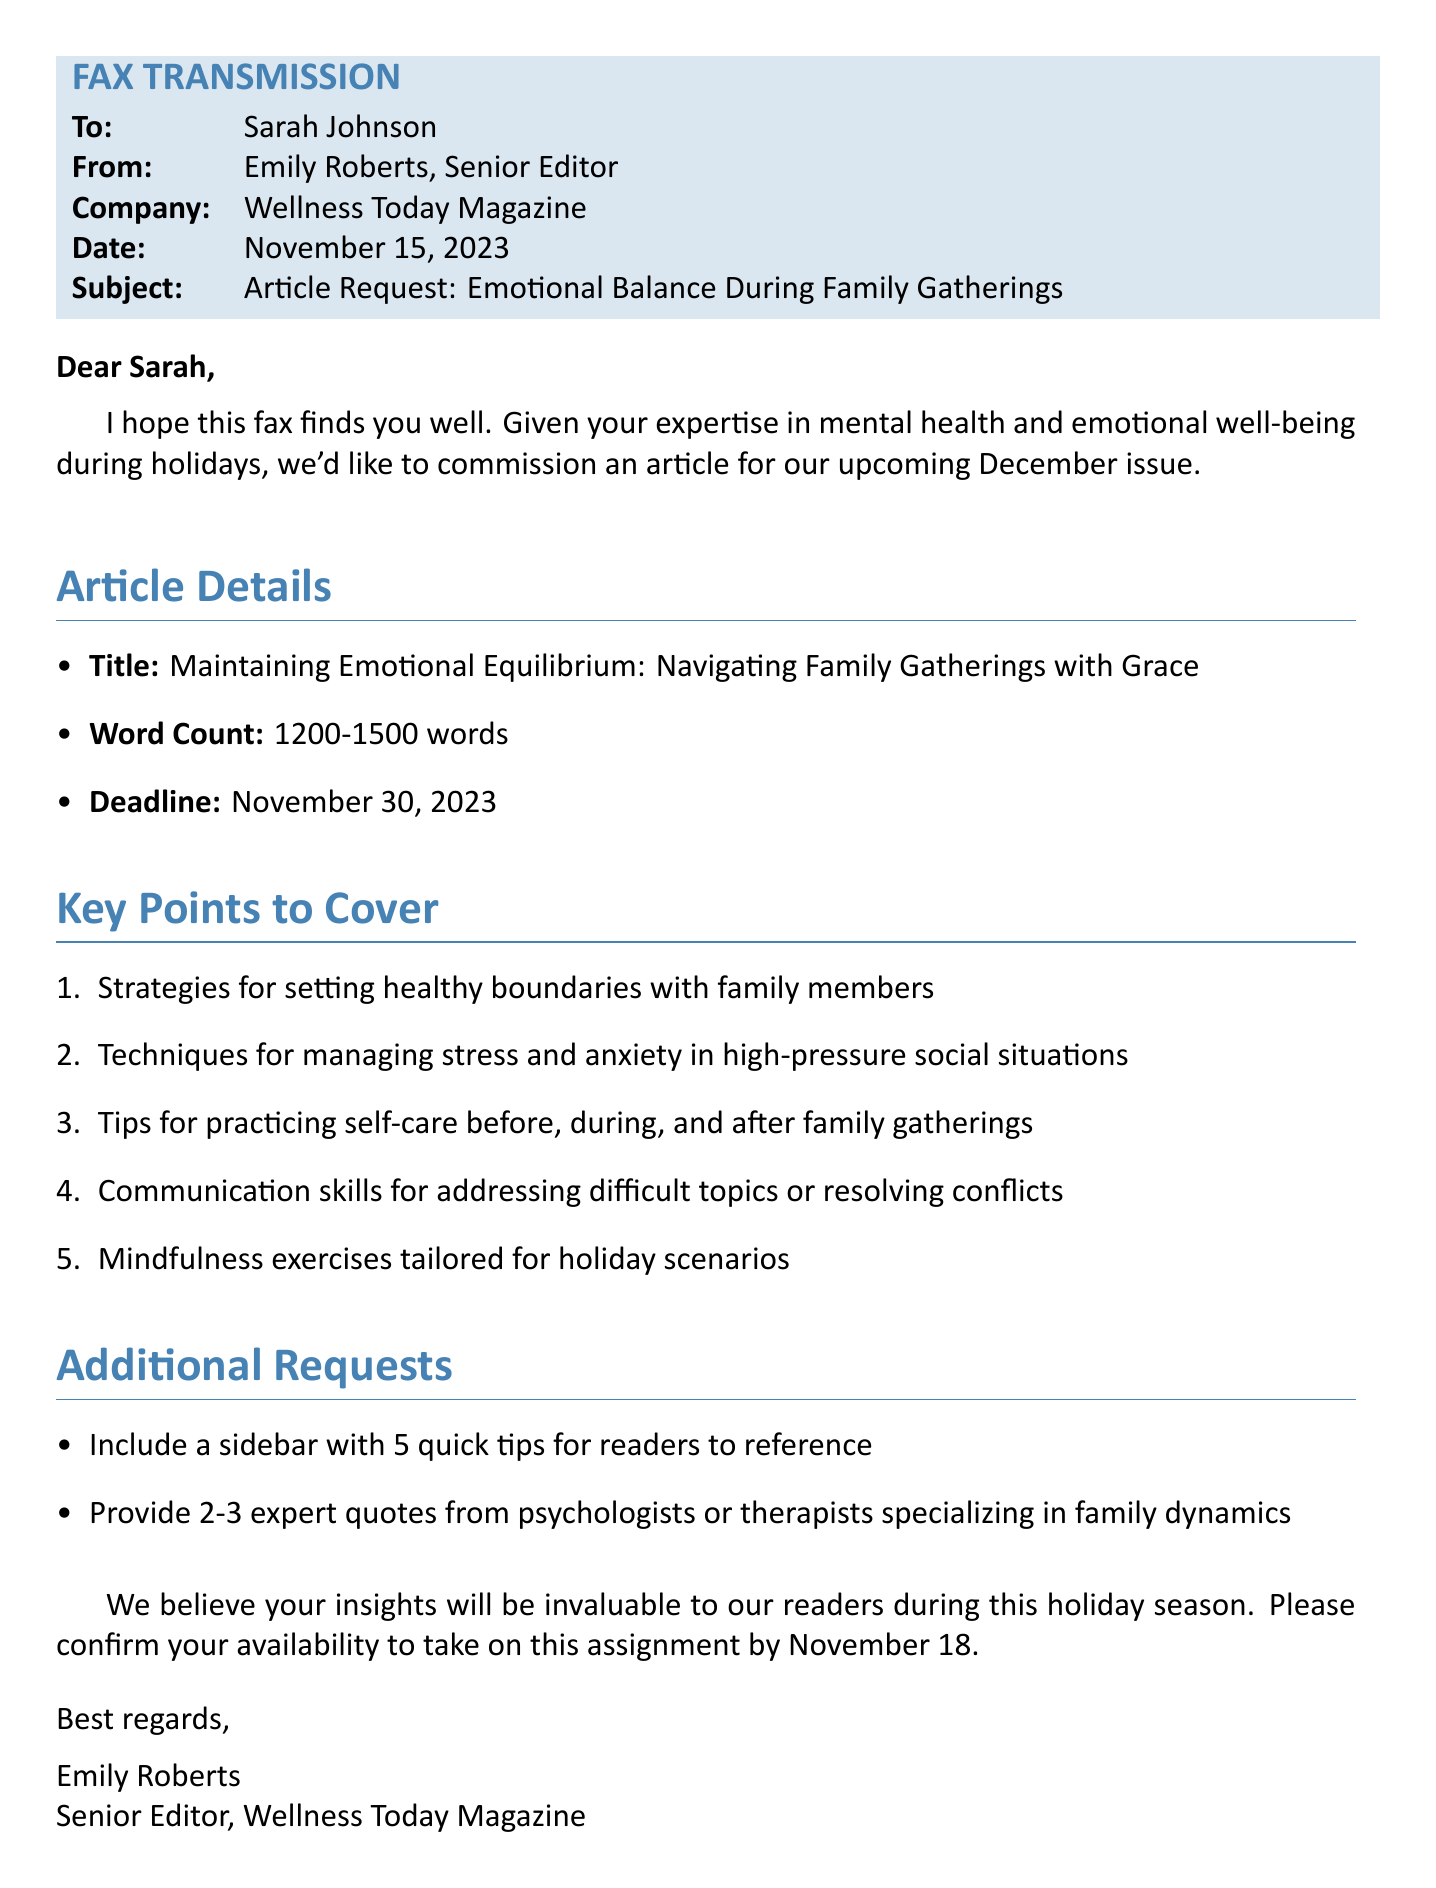What is the recipient's name? The fax is addressed to Sarah Johnson.
Answer: Sarah Johnson Who is the sender of the fax? The fax is sent by Emily Roberts, Senior Editor.
Answer: Emily Roberts What is the subject of the fax? The subject line specifies the topic of the article request.
Answer: Article Request: Emotional Balance During Family Gatherings What is the word count for the article? The document states the desired word count range.
Answer: 1200-1500 words What is the deadline for the article submission? The document includes a specific submission date for the article.
Answer: November 30, 2023 What strategy is suggested for family interactions? There is a key point regarding how to handle family dynamics.
Answer: Setting healthy boundaries How many expert quotes should be included? The document specifies the number of expert quotes to provide.
Answer: 2-3 What is the title of the requested article? The title that reflects the focus of the article is given in the document.
Answer: Maintaining Emotional Equilibrium: Navigating Family Gatherings with Grace When did the sender hope the recipient was well? The sender opens with a well-wishing statement.
Answer: I hope this fax finds you well What additional feature is requested to accompany the article? The document requests specific supplementary content to be included.
Answer: A sidebar with 5 quick tips 